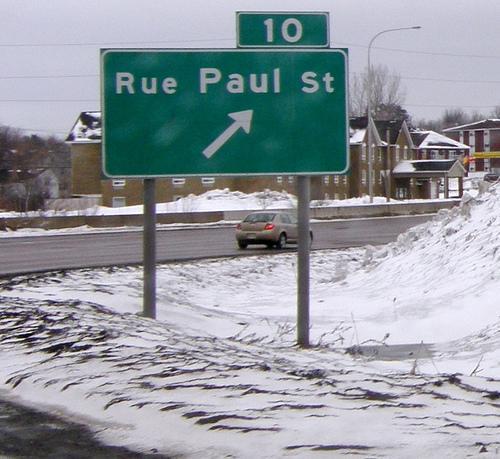How many cars are in this picture?
Give a very brief answer. 1. How many poles are holding up the sign?
Give a very brief answer. 2. 